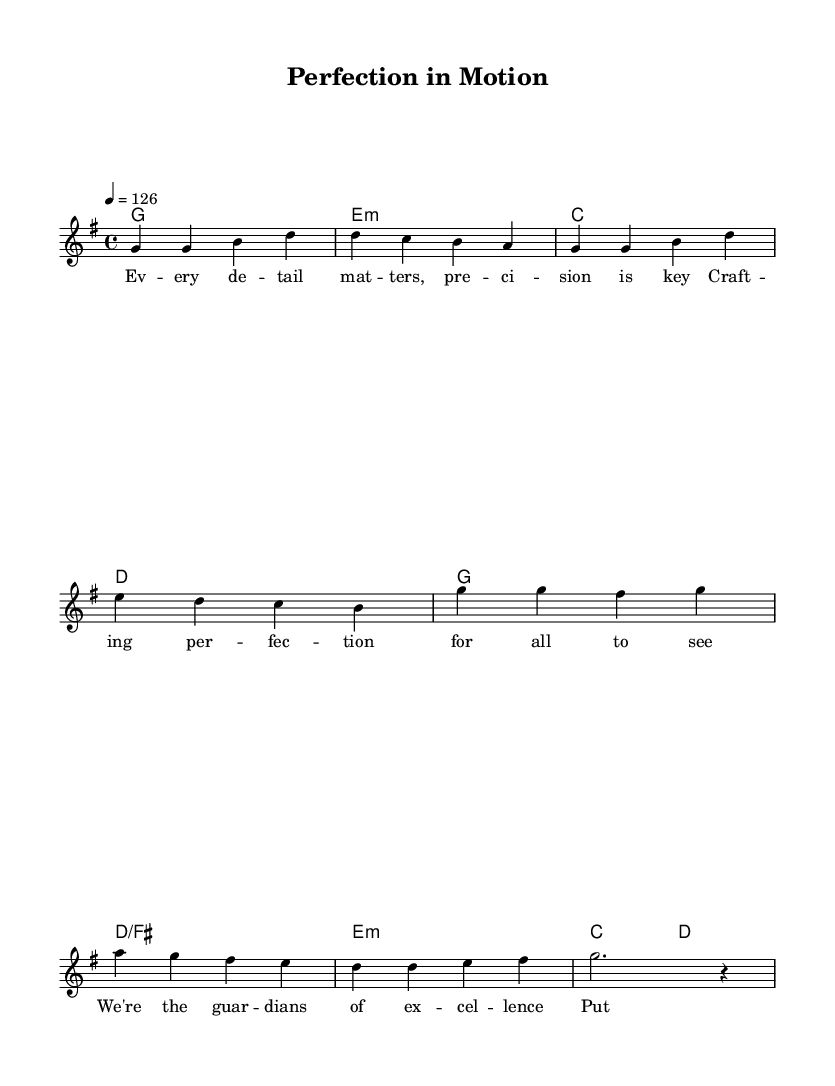What is the key signature of this music? The key signature is G major, which contains one sharp (F#) noted at the beginning of the sheet music.
Answer: G major What is the time signature of this music? The time signature is 4/4, indicated at the beginning with a '4' on top and another '4' below, which signifies four beats per measure.
Answer: 4/4 What is the tempo marking of this piece? The tempo marking is quarter note equals 126, shown as "4 = 126" at the beginning, indicating the speed at which the piece should be played.
Answer: 126 How many measures are in the verse section? The verse section consists of 4 measures, as counted through the melody line in the sheet music where the melody starts and ends.
Answer: 4 What is the primary theme expressed in the lyrics? The primary theme in the lyrics expresses the importance of attention to detail and precision in crafting perfection, evident in the words chosen throughout both the verse and chorus.
Answer: Attention to detail Which chord appears most frequently in the harmonies? The G major chord appears most frequently as the starting chord in both the verse and chorus sections, indicating its centrality to the piece.
Answer: G major 